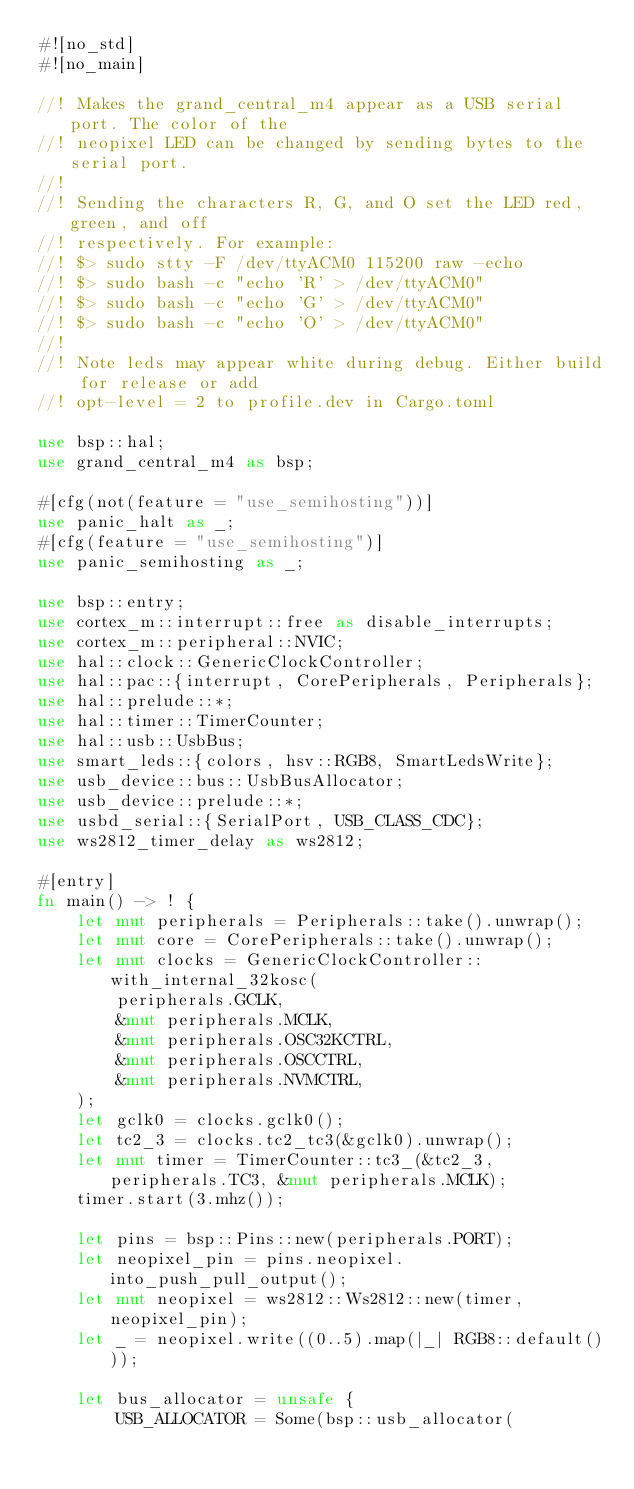<code> <loc_0><loc_0><loc_500><loc_500><_Rust_>#![no_std]
#![no_main]

//! Makes the grand_central_m4 appear as a USB serial port. The color of the
//! neopixel LED can be changed by sending bytes to the serial port.
//!
//! Sending the characters R, G, and O set the LED red, green, and off
//! respectively. For example:
//! $> sudo stty -F /dev/ttyACM0 115200 raw -echo
//! $> sudo bash -c "echo 'R' > /dev/ttyACM0"
//! $> sudo bash -c "echo 'G' > /dev/ttyACM0"
//! $> sudo bash -c "echo 'O' > /dev/ttyACM0"
//!
//! Note leds may appear white during debug. Either build for release or add
//! opt-level = 2 to profile.dev in Cargo.toml

use bsp::hal;
use grand_central_m4 as bsp;

#[cfg(not(feature = "use_semihosting"))]
use panic_halt as _;
#[cfg(feature = "use_semihosting")]
use panic_semihosting as _;

use bsp::entry;
use cortex_m::interrupt::free as disable_interrupts;
use cortex_m::peripheral::NVIC;
use hal::clock::GenericClockController;
use hal::pac::{interrupt, CorePeripherals, Peripherals};
use hal::prelude::*;
use hal::timer::TimerCounter;
use hal::usb::UsbBus;
use smart_leds::{colors, hsv::RGB8, SmartLedsWrite};
use usb_device::bus::UsbBusAllocator;
use usb_device::prelude::*;
use usbd_serial::{SerialPort, USB_CLASS_CDC};
use ws2812_timer_delay as ws2812;

#[entry]
fn main() -> ! {
    let mut peripherals = Peripherals::take().unwrap();
    let mut core = CorePeripherals::take().unwrap();
    let mut clocks = GenericClockController::with_internal_32kosc(
        peripherals.GCLK,
        &mut peripherals.MCLK,
        &mut peripherals.OSC32KCTRL,
        &mut peripherals.OSCCTRL,
        &mut peripherals.NVMCTRL,
    );
    let gclk0 = clocks.gclk0();
    let tc2_3 = clocks.tc2_tc3(&gclk0).unwrap();
    let mut timer = TimerCounter::tc3_(&tc2_3, peripherals.TC3, &mut peripherals.MCLK);
    timer.start(3.mhz());

    let pins = bsp::Pins::new(peripherals.PORT);
    let neopixel_pin = pins.neopixel.into_push_pull_output();
    let mut neopixel = ws2812::Ws2812::new(timer, neopixel_pin);
    let _ = neopixel.write((0..5).map(|_| RGB8::default()));

    let bus_allocator = unsafe {
        USB_ALLOCATOR = Some(bsp::usb_allocator(</code> 